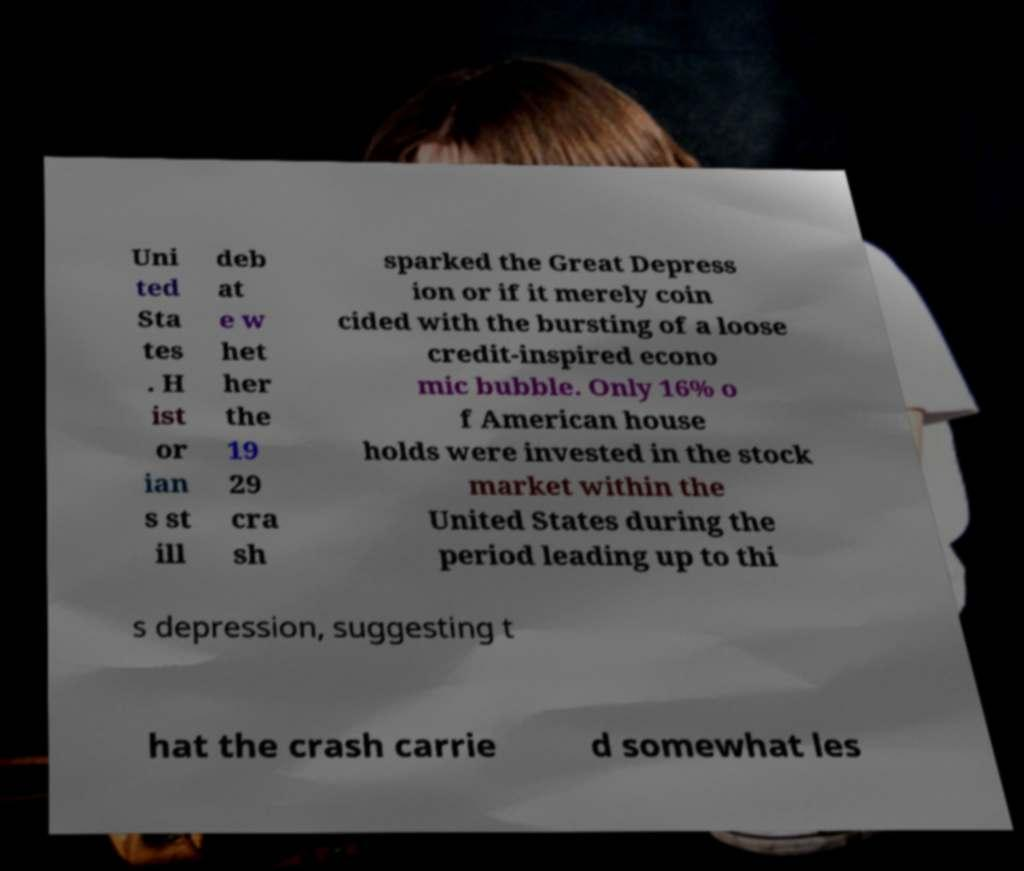There's text embedded in this image that I need extracted. Can you transcribe it verbatim? Uni ted Sta tes . H ist or ian s st ill deb at e w het her the 19 29 cra sh sparked the Great Depress ion or if it merely coin cided with the bursting of a loose credit-inspired econo mic bubble. Only 16% o f American house holds were invested in the stock market within the United States during the period leading up to thi s depression, suggesting t hat the crash carrie d somewhat les 